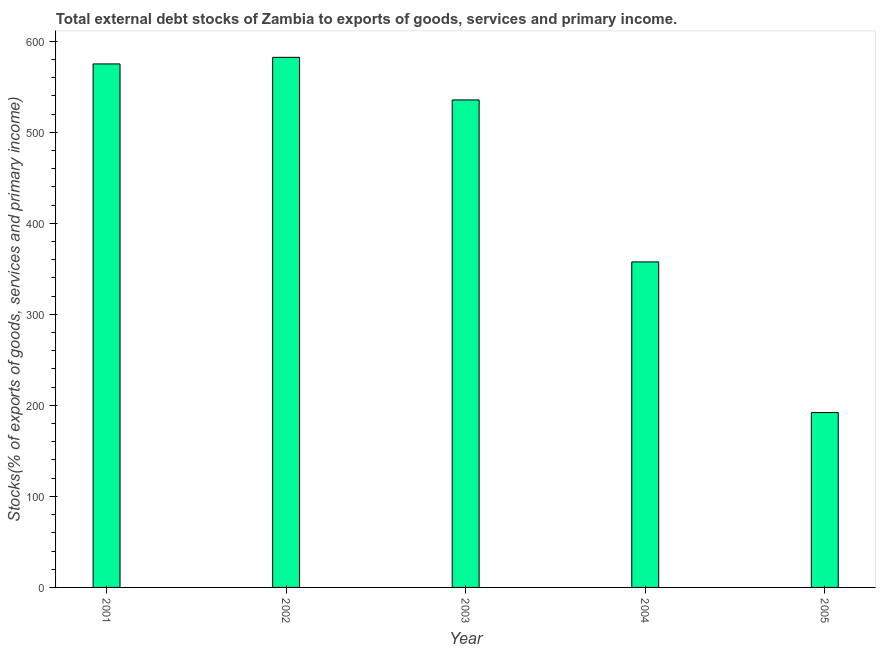Does the graph contain any zero values?
Keep it short and to the point. No. What is the title of the graph?
Keep it short and to the point. Total external debt stocks of Zambia to exports of goods, services and primary income. What is the label or title of the Y-axis?
Ensure brevity in your answer.  Stocks(% of exports of goods, services and primary income). What is the external debt stocks in 2005?
Ensure brevity in your answer.  192.11. Across all years, what is the maximum external debt stocks?
Keep it short and to the point. 582.4. Across all years, what is the minimum external debt stocks?
Keep it short and to the point. 192.11. What is the sum of the external debt stocks?
Keep it short and to the point. 2242.87. What is the difference between the external debt stocks in 2003 and 2004?
Offer a terse response. 177.94. What is the average external debt stocks per year?
Make the answer very short. 448.57. What is the median external debt stocks?
Provide a short and direct response. 535.58. In how many years, is the external debt stocks greater than 360 %?
Provide a short and direct response. 3. What is the ratio of the external debt stocks in 2002 to that in 2004?
Make the answer very short. 1.63. Is the external debt stocks in 2002 less than that in 2005?
Your answer should be compact. No. Is the difference between the external debt stocks in 2001 and 2004 greater than the difference between any two years?
Make the answer very short. No. What is the difference between the highest and the second highest external debt stocks?
Provide a succinct answer. 7.26. Is the sum of the external debt stocks in 2003 and 2004 greater than the maximum external debt stocks across all years?
Make the answer very short. Yes. What is the difference between the highest and the lowest external debt stocks?
Offer a very short reply. 390.29. In how many years, is the external debt stocks greater than the average external debt stocks taken over all years?
Make the answer very short. 3. Are all the bars in the graph horizontal?
Provide a short and direct response. No. Are the values on the major ticks of Y-axis written in scientific E-notation?
Your answer should be compact. No. What is the Stocks(% of exports of goods, services and primary income) in 2001?
Offer a very short reply. 575.14. What is the Stocks(% of exports of goods, services and primary income) of 2002?
Make the answer very short. 582.4. What is the Stocks(% of exports of goods, services and primary income) of 2003?
Your response must be concise. 535.58. What is the Stocks(% of exports of goods, services and primary income) of 2004?
Offer a very short reply. 357.64. What is the Stocks(% of exports of goods, services and primary income) in 2005?
Offer a very short reply. 192.11. What is the difference between the Stocks(% of exports of goods, services and primary income) in 2001 and 2002?
Offer a terse response. -7.26. What is the difference between the Stocks(% of exports of goods, services and primary income) in 2001 and 2003?
Make the answer very short. 39.55. What is the difference between the Stocks(% of exports of goods, services and primary income) in 2001 and 2004?
Keep it short and to the point. 217.49. What is the difference between the Stocks(% of exports of goods, services and primary income) in 2001 and 2005?
Offer a terse response. 383.03. What is the difference between the Stocks(% of exports of goods, services and primary income) in 2002 and 2003?
Provide a short and direct response. 46.81. What is the difference between the Stocks(% of exports of goods, services and primary income) in 2002 and 2004?
Keep it short and to the point. 224.75. What is the difference between the Stocks(% of exports of goods, services and primary income) in 2002 and 2005?
Keep it short and to the point. 390.29. What is the difference between the Stocks(% of exports of goods, services and primary income) in 2003 and 2004?
Give a very brief answer. 177.94. What is the difference between the Stocks(% of exports of goods, services and primary income) in 2003 and 2005?
Provide a short and direct response. 343.48. What is the difference between the Stocks(% of exports of goods, services and primary income) in 2004 and 2005?
Offer a very short reply. 165.54. What is the ratio of the Stocks(% of exports of goods, services and primary income) in 2001 to that in 2002?
Provide a succinct answer. 0.99. What is the ratio of the Stocks(% of exports of goods, services and primary income) in 2001 to that in 2003?
Ensure brevity in your answer.  1.07. What is the ratio of the Stocks(% of exports of goods, services and primary income) in 2001 to that in 2004?
Provide a succinct answer. 1.61. What is the ratio of the Stocks(% of exports of goods, services and primary income) in 2001 to that in 2005?
Give a very brief answer. 2.99. What is the ratio of the Stocks(% of exports of goods, services and primary income) in 2002 to that in 2003?
Offer a very short reply. 1.09. What is the ratio of the Stocks(% of exports of goods, services and primary income) in 2002 to that in 2004?
Make the answer very short. 1.63. What is the ratio of the Stocks(% of exports of goods, services and primary income) in 2002 to that in 2005?
Your answer should be very brief. 3.03. What is the ratio of the Stocks(% of exports of goods, services and primary income) in 2003 to that in 2004?
Keep it short and to the point. 1.5. What is the ratio of the Stocks(% of exports of goods, services and primary income) in 2003 to that in 2005?
Your response must be concise. 2.79. What is the ratio of the Stocks(% of exports of goods, services and primary income) in 2004 to that in 2005?
Give a very brief answer. 1.86. 